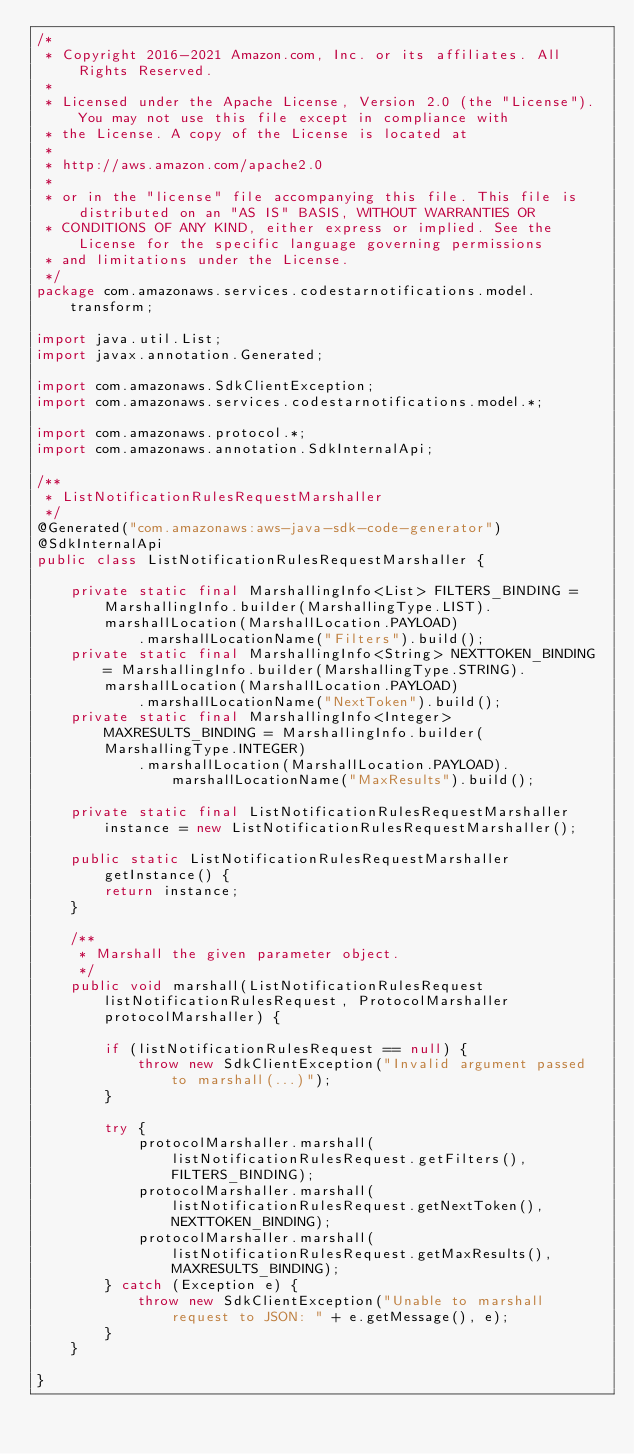Convert code to text. <code><loc_0><loc_0><loc_500><loc_500><_Java_>/*
 * Copyright 2016-2021 Amazon.com, Inc. or its affiliates. All Rights Reserved.
 * 
 * Licensed under the Apache License, Version 2.0 (the "License"). You may not use this file except in compliance with
 * the License. A copy of the License is located at
 * 
 * http://aws.amazon.com/apache2.0
 * 
 * or in the "license" file accompanying this file. This file is distributed on an "AS IS" BASIS, WITHOUT WARRANTIES OR
 * CONDITIONS OF ANY KIND, either express or implied. See the License for the specific language governing permissions
 * and limitations under the License.
 */
package com.amazonaws.services.codestarnotifications.model.transform;

import java.util.List;
import javax.annotation.Generated;

import com.amazonaws.SdkClientException;
import com.amazonaws.services.codestarnotifications.model.*;

import com.amazonaws.protocol.*;
import com.amazonaws.annotation.SdkInternalApi;

/**
 * ListNotificationRulesRequestMarshaller
 */
@Generated("com.amazonaws:aws-java-sdk-code-generator")
@SdkInternalApi
public class ListNotificationRulesRequestMarshaller {

    private static final MarshallingInfo<List> FILTERS_BINDING = MarshallingInfo.builder(MarshallingType.LIST).marshallLocation(MarshallLocation.PAYLOAD)
            .marshallLocationName("Filters").build();
    private static final MarshallingInfo<String> NEXTTOKEN_BINDING = MarshallingInfo.builder(MarshallingType.STRING).marshallLocation(MarshallLocation.PAYLOAD)
            .marshallLocationName("NextToken").build();
    private static final MarshallingInfo<Integer> MAXRESULTS_BINDING = MarshallingInfo.builder(MarshallingType.INTEGER)
            .marshallLocation(MarshallLocation.PAYLOAD).marshallLocationName("MaxResults").build();

    private static final ListNotificationRulesRequestMarshaller instance = new ListNotificationRulesRequestMarshaller();

    public static ListNotificationRulesRequestMarshaller getInstance() {
        return instance;
    }

    /**
     * Marshall the given parameter object.
     */
    public void marshall(ListNotificationRulesRequest listNotificationRulesRequest, ProtocolMarshaller protocolMarshaller) {

        if (listNotificationRulesRequest == null) {
            throw new SdkClientException("Invalid argument passed to marshall(...)");
        }

        try {
            protocolMarshaller.marshall(listNotificationRulesRequest.getFilters(), FILTERS_BINDING);
            protocolMarshaller.marshall(listNotificationRulesRequest.getNextToken(), NEXTTOKEN_BINDING);
            protocolMarshaller.marshall(listNotificationRulesRequest.getMaxResults(), MAXRESULTS_BINDING);
        } catch (Exception e) {
            throw new SdkClientException("Unable to marshall request to JSON: " + e.getMessage(), e);
        }
    }

}
</code> 